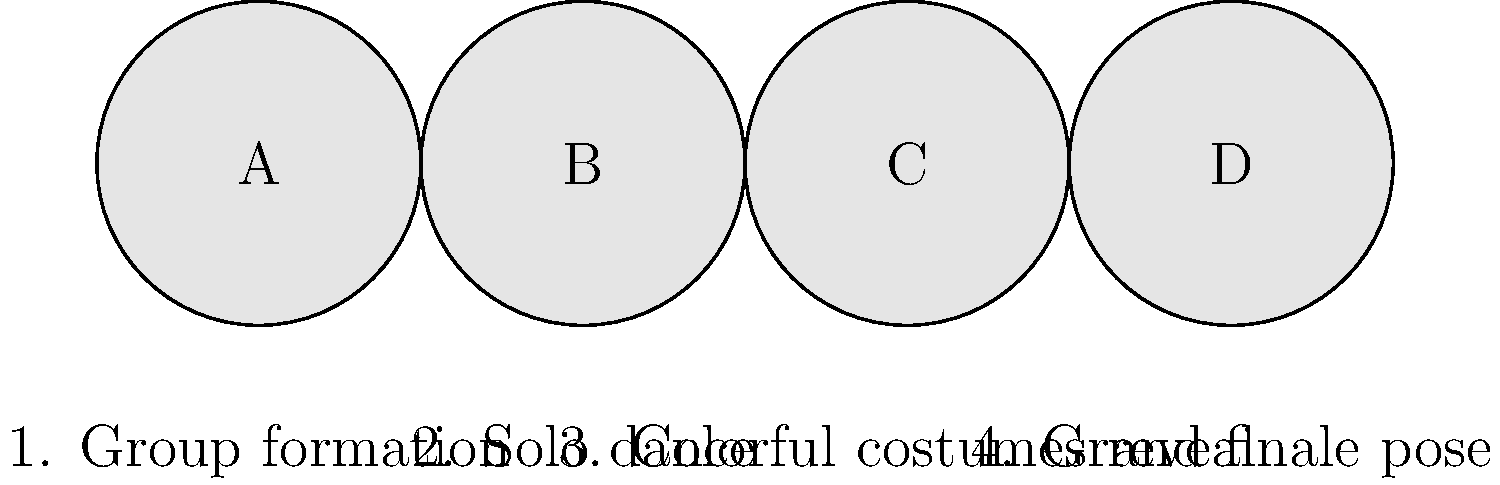Arrange the following scenes from the iconic "Dola Re Dola" dance number from the movie "Devdas" in chronological order:

A. Solo dance
B. Grand finale pose
C. Group formation
D. Colorful costumes reveal To arrange the scenes from the "Dola Re Dola" dance number in chronological order, let's analyze the typical structure of a Bollywood dance sequence:

1. Group formation: The dance usually begins with dancers entering the scene and forming an initial group arrangement. This sets the stage for the performance.

2. Solo dance: After the group formation, one of the lead dancers (in this case, either Madhuri Dixit or Aishwarya Rai) would perform a solo part to showcase their individual skills.

3. Colorful costumes reveal: As the dance progresses, there's often a moment where the dancers' costumes are dramatically revealed, adding to the visual spectacle.

4. Grand finale pose: The dance number typically concludes with all dancers striking a powerful, synchronized pose to end the performance on a high note.

Given this structure, the correct chronological order of the scenes would be:

C (Group formation) → A (Solo dance) → D (Colorful costumes reveal) → B (Grand finale pose)
Answer: C, A, D, B 